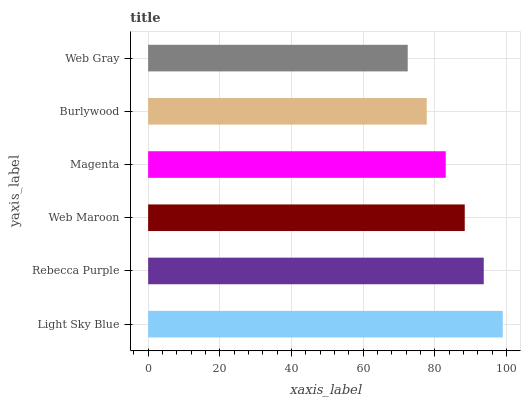Is Web Gray the minimum?
Answer yes or no. Yes. Is Light Sky Blue the maximum?
Answer yes or no. Yes. Is Rebecca Purple the minimum?
Answer yes or no. No. Is Rebecca Purple the maximum?
Answer yes or no. No. Is Light Sky Blue greater than Rebecca Purple?
Answer yes or no. Yes. Is Rebecca Purple less than Light Sky Blue?
Answer yes or no. Yes. Is Rebecca Purple greater than Light Sky Blue?
Answer yes or no. No. Is Light Sky Blue less than Rebecca Purple?
Answer yes or no. No. Is Web Maroon the high median?
Answer yes or no. Yes. Is Magenta the low median?
Answer yes or no. Yes. Is Burlywood the high median?
Answer yes or no. No. Is Burlywood the low median?
Answer yes or no. No. 